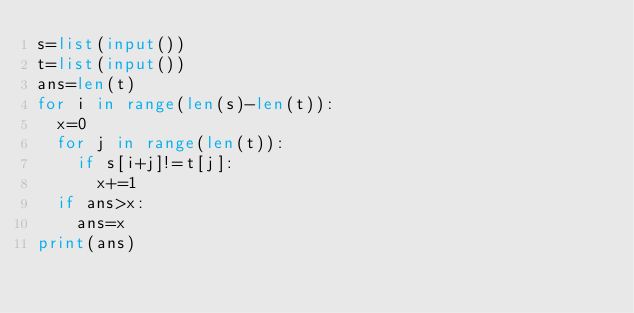Convert code to text. <code><loc_0><loc_0><loc_500><loc_500><_Python_>s=list(input())
t=list(input())
ans=len(t)
for i in range(len(s)-len(t)):
  x=0
  for j in range(len(t)):
    if s[i+j]!=t[j]:
      x+=1
  if ans>x:
    ans=x
print(ans)
               </code> 